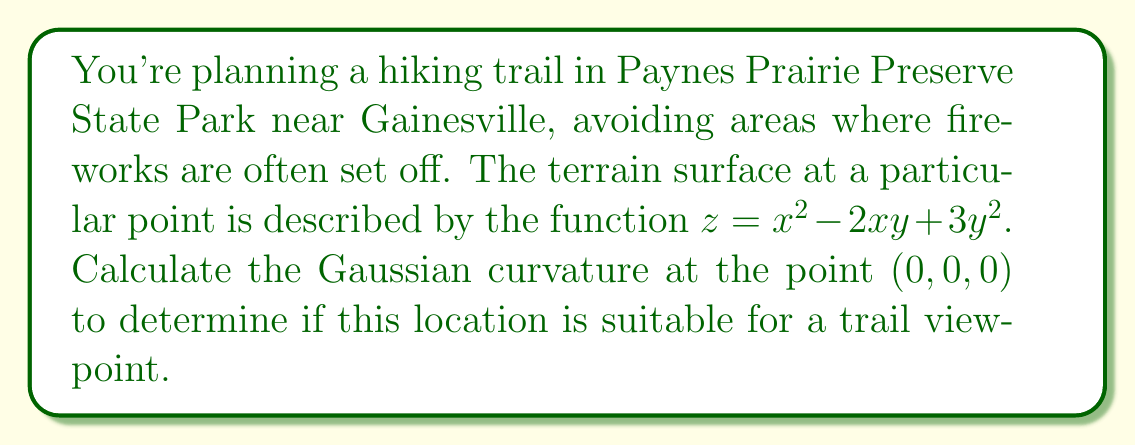Provide a solution to this math problem. To compute the Gaussian curvature, we'll follow these steps:

1) The Gaussian curvature K is given by:
   $$K = \frac{LN - M^2}{EG - F^2}$$
   where L, M, N are coefficients of the second fundamental form, and E, F, G are coefficients of the first fundamental form.

2) For a surface $z = f(x,y)$, we have:
   $$E = 1 + f_x^2, \quad F = f_x f_y, \quad G = 1 + f_y^2$$
   $$L = \frac{f_{xx}}{\sqrt{1 + f_x^2 + f_y^2}}, \quad M = \frac{f_{xy}}{\sqrt{1 + f_x^2 + f_y^2}}, \quad N = \frac{f_{yy}}{\sqrt{1 + f_x^2 + f_y^2}}$$

3) Let's compute the partial derivatives:
   $f_x = 2x - 2y$
   $f_y = -2x + 6y$
   $f_{xx} = 2$
   $f_{xy} = -2$
   $f_{yy} = 6$

4) At (0, 0, 0):
   $f_x = f_y = 0$
   $f_{xx} = 2$, $f_{xy} = -2$, $f_{yy} = 6$

5) Now we can compute E, F, G, L, M, N at (0, 0, 0):
   $E = G = 1$, $F = 0$
   $L = 2$, $M = -2$, $N = 6$

6) Substituting into the Gaussian curvature formula:
   $$K = \frac{LN - M^2}{EG - F^2} = \frac{(2)(6) - (-2)^2}{(1)(1) - 0^2} = \frac{12 - 4}{1} = 8$$

Therefore, the Gaussian curvature at (0, 0, 0) is 8.
Answer: $K = 8$ 